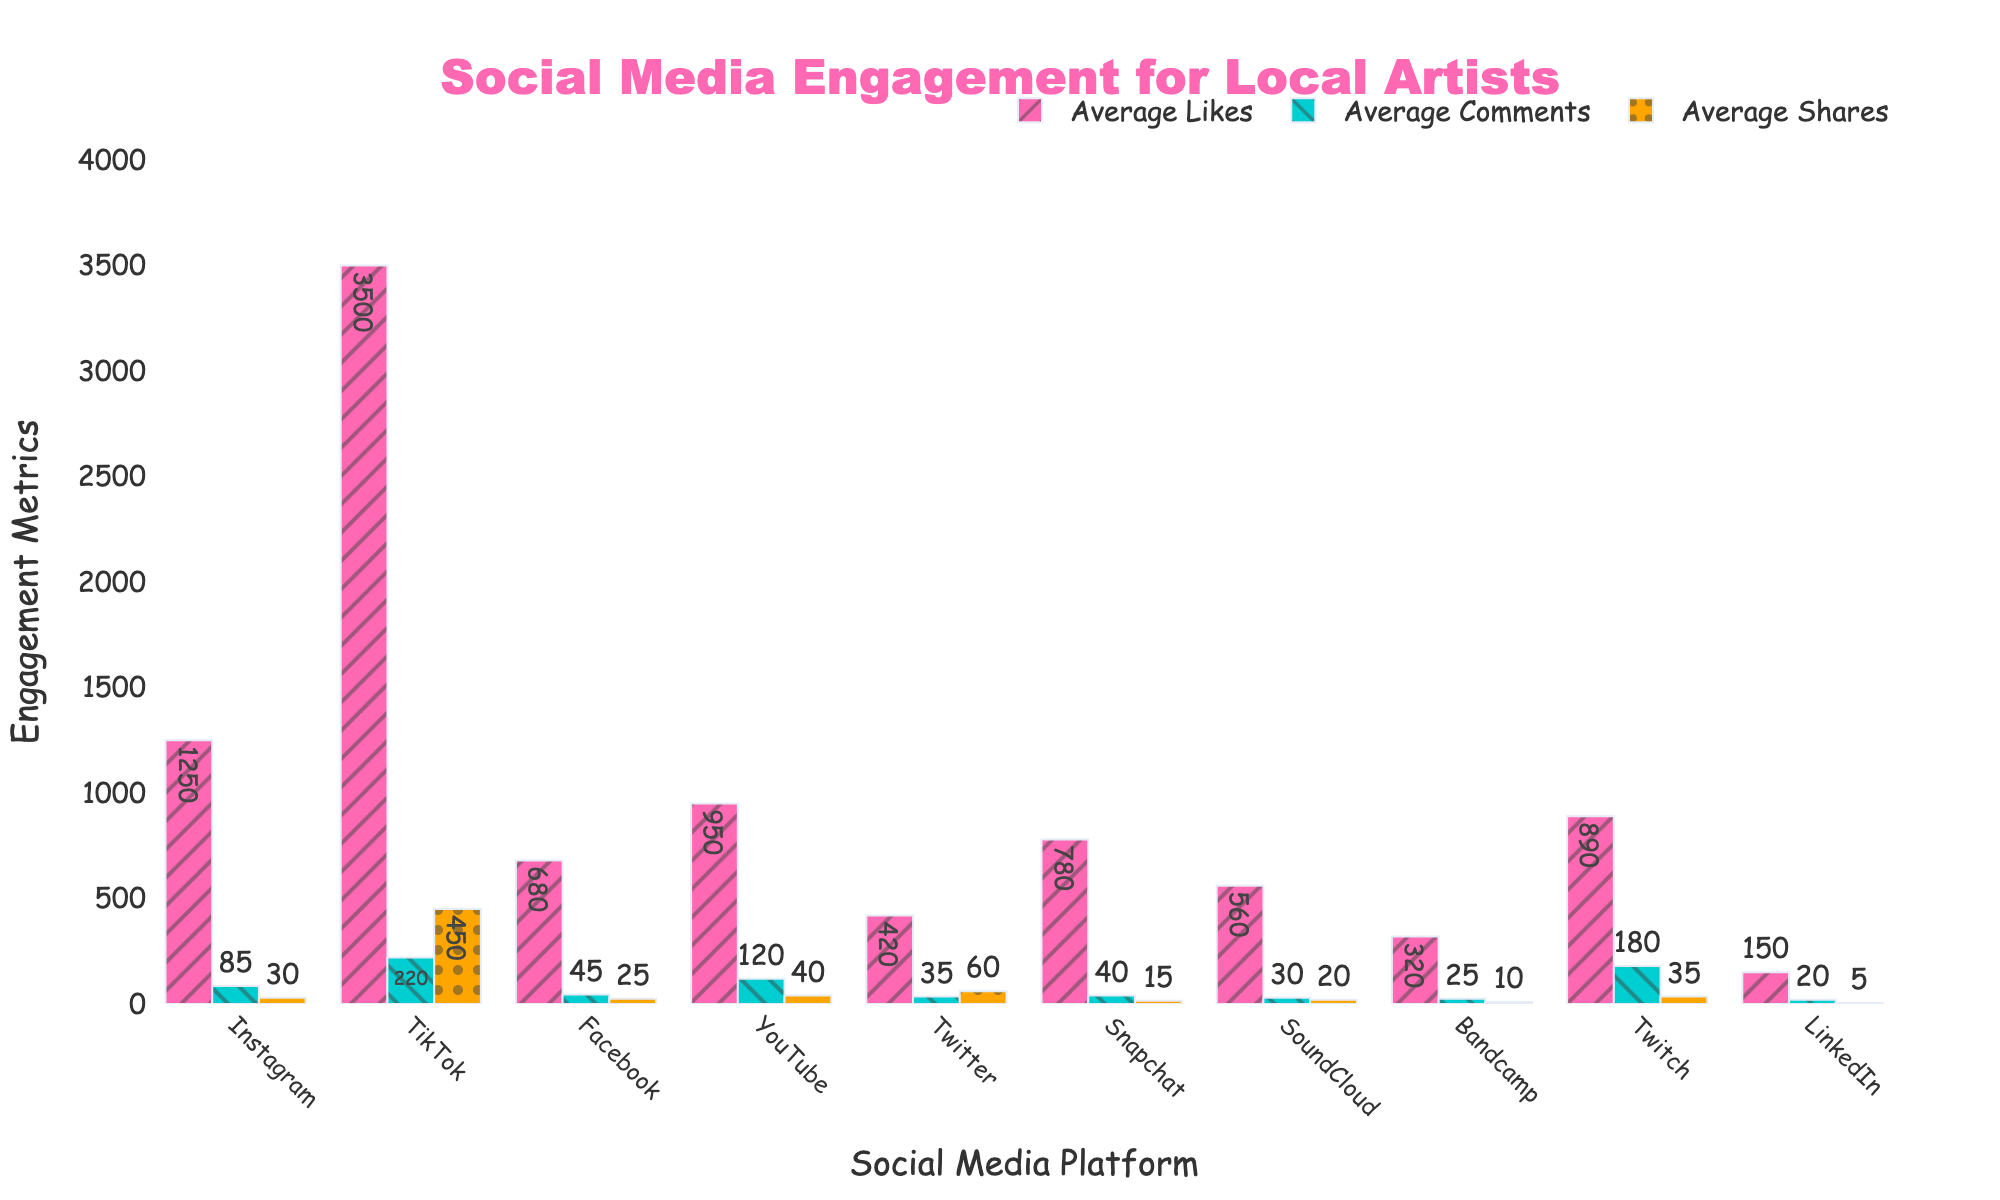Which platform has the highest average comments? TikTok has the highest bar for average comments, which clearly stands out among the other bars in this category.
Answer: TikTok Which platform has the lowest average shares? LinkedIn has the smallest bar for average shares, indicating it has the lowest value compared to other platforms.
Answer: LinkedIn Compare the average likes on Instagram and YouTube. Which platform has more? By visually comparing the height of the bars for average likes on Instagram and YouTube, Instagram's bar is taller, meaning Instagram has more average likes than YouTube.
Answer: Instagram What is the total number of average shares for Facebook, Snapchat, and SoundCloud? Adding the values of average shares: Facebook (25) + Snapchat (15) + SoundCloud (20) = 60.
Answer: 60 Is the average number of comments on YouTube greater than the average number of likes on Twitter? Comparing the bars, YouTube's average comments (120) are greater than Twitter's average likes (420).
Answer: No Which platform has a higher combined average for likes and comments: Twitch or SoundCloud? Calculate and compare: Twitch's average likes (890) + average comments (180) = 1070; SoundCloud's average likes (560) + average comments (30) = 590. Twitch has a higher combined average.
Answer: Twitch What is the difference between the average shares of TikTok and Instagram? Subtract average shares of Instagram (30) from TikTok (450): 450 - 30 = 420.
Answer: 420 What is the ratio of TikTok's average comments to LinkedIn's average comments? Divide TikTok's average comments (220) by LinkedIn's average comments (20): 220 / 20 = 11.
Answer: 11 Which metric (likes, comments, shares) is most evenly distributed across platforms based on the visual height of the bars? Comparing the uniformity of bar heights across platforms, average shares appear to be the most evenly distributed.
Answer: Shares How does the number of average likes on Twitter compare to average comments on Snapchat? The bar for average likes on Twitter (420) is considerably higher than the bar for average comments on Snapchat (40).
Answer: Twitter has more likes 